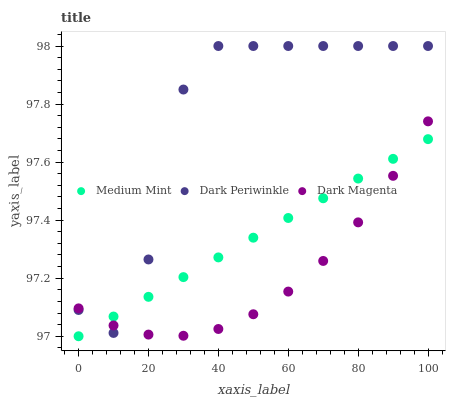Does Dark Magenta have the minimum area under the curve?
Answer yes or no. Yes. Does Dark Periwinkle have the maximum area under the curve?
Answer yes or no. Yes. Does Dark Periwinkle have the minimum area under the curve?
Answer yes or no. No. Does Dark Magenta have the maximum area under the curve?
Answer yes or no. No. Is Medium Mint the smoothest?
Answer yes or no. Yes. Is Dark Periwinkle the roughest?
Answer yes or no. Yes. Is Dark Magenta the smoothest?
Answer yes or no. No. Is Dark Magenta the roughest?
Answer yes or no. No. Does Medium Mint have the lowest value?
Answer yes or no. Yes. Does Dark Magenta have the lowest value?
Answer yes or no. No. Does Dark Periwinkle have the highest value?
Answer yes or no. Yes. Does Dark Magenta have the highest value?
Answer yes or no. No. Does Medium Mint intersect Dark Magenta?
Answer yes or no. Yes. Is Medium Mint less than Dark Magenta?
Answer yes or no. No. Is Medium Mint greater than Dark Magenta?
Answer yes or no. No. 